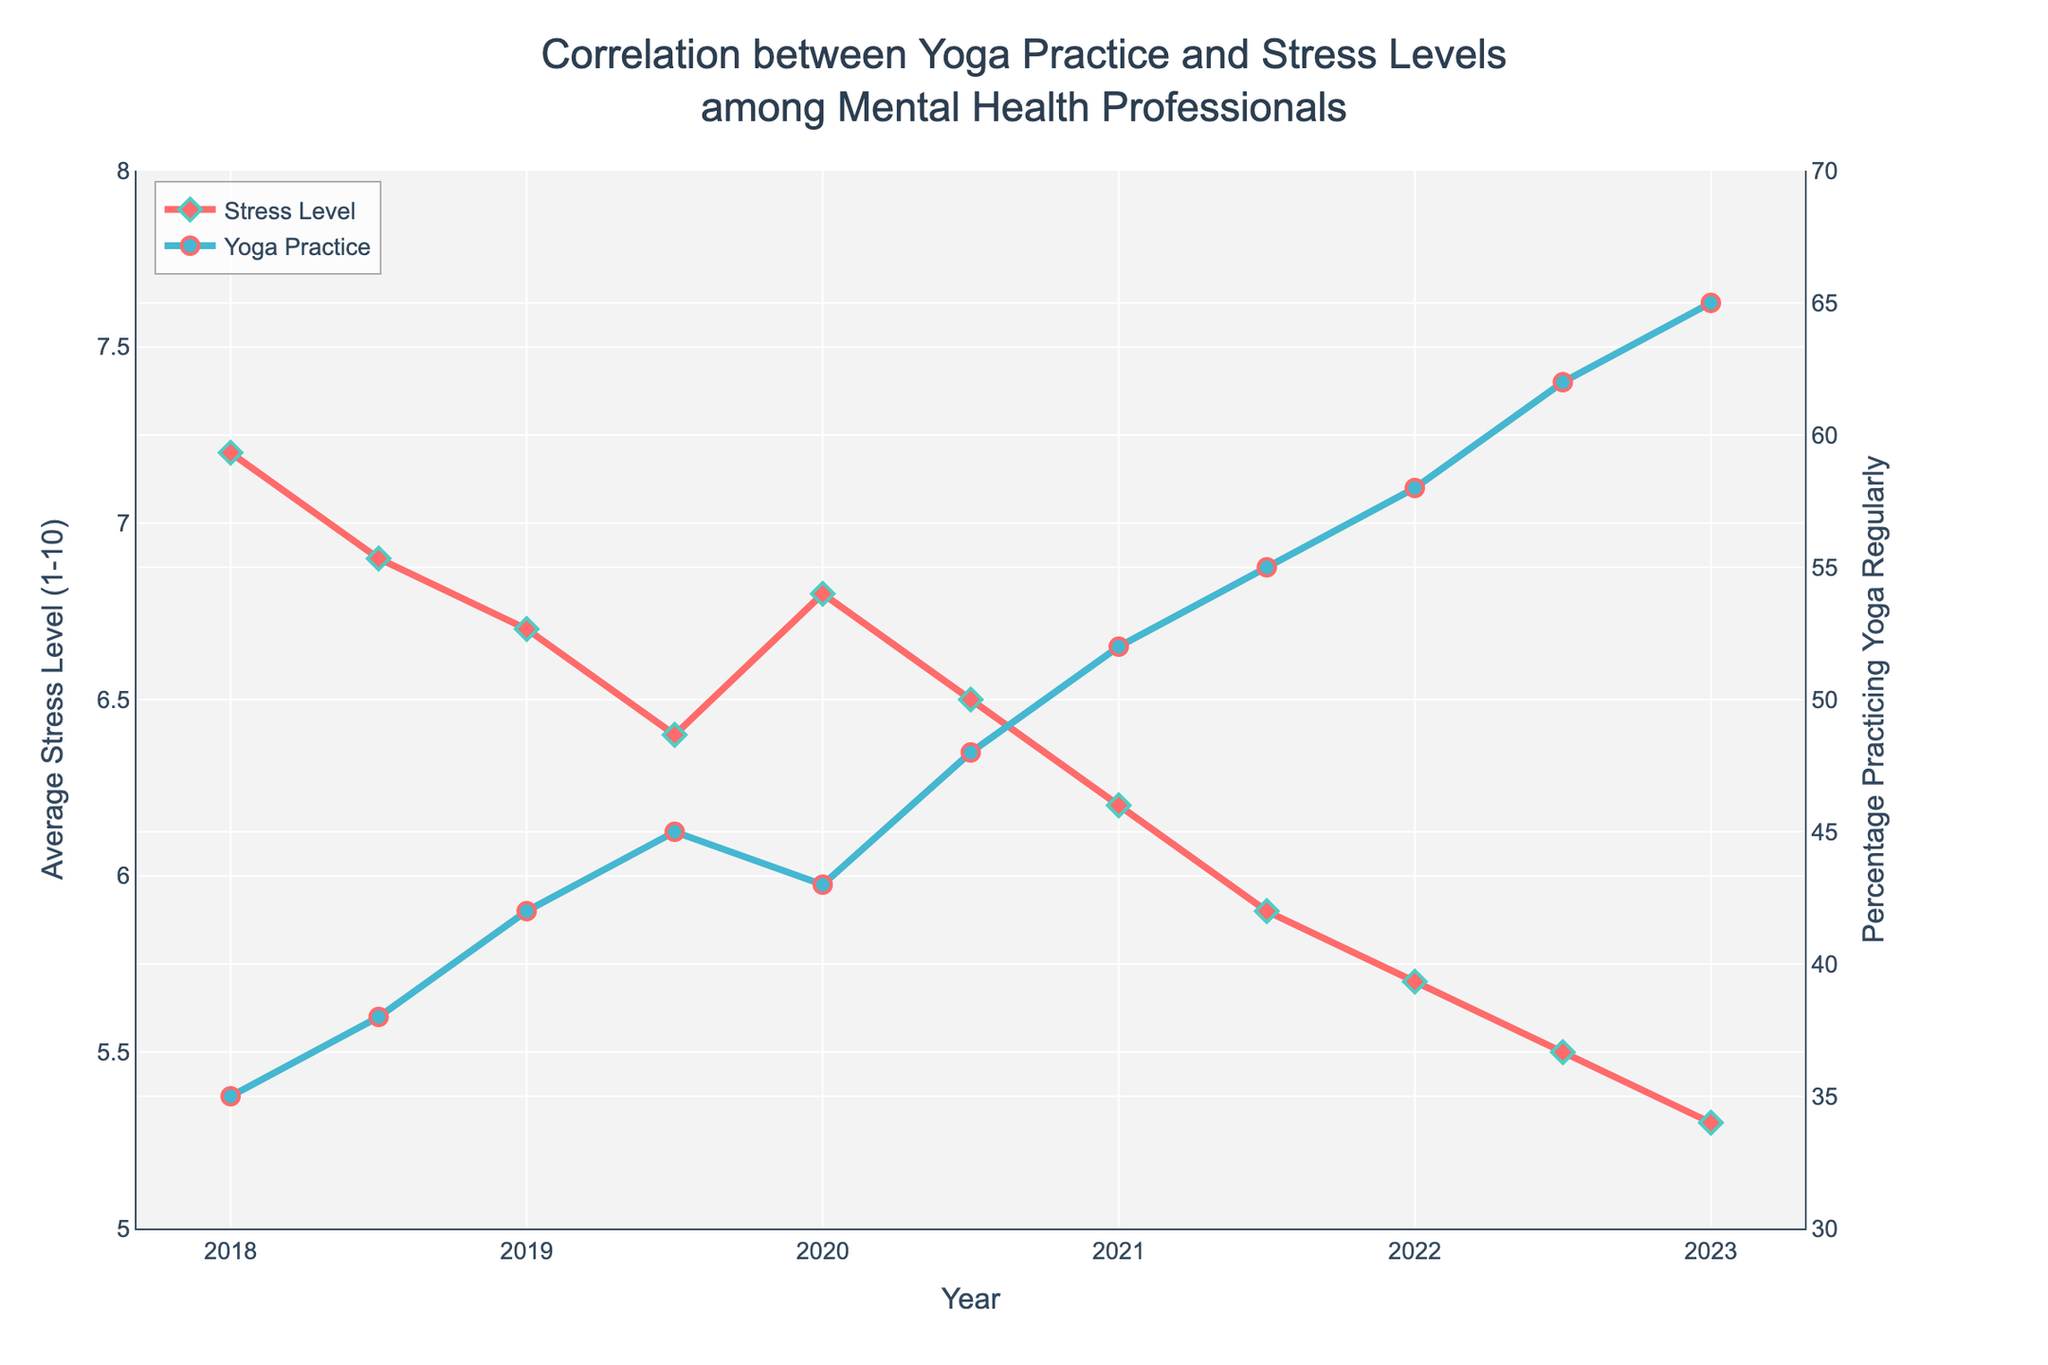What trend do you observe in the stress levels from 2018 to 2023? Observing the red line representing stress levels, it starts at 7.2 in 2018 and consistently decreases, reaching 5.3 by 2023.
Answer: Decreasing In which year was the highest percentage of mental health professionals practicing yoga regularly? Following the blue line indicating percentage yoga practice, it peaks at 65% in 2023.
Answer: 2023 What is the difference in the average stress levels between 2018 and 2023? The average stress level in 2018 is 7.2, while in 2023 it is 5.3. The difference is 7.2 - 5.3 = 1.9.
Answer: 1.9 How did the percentage of mental health professionals practicing yoga regularly change between 2020.5 and 2021.5? In 2020.5, 48% were practicing yoga regularly, while in 2021.5, it was 55%. The change is 55% - 48% = 7%.
Answer: 7% Which year between 2020 and 2023 saw the largest decline in stress levels? From 2020 to 2020.5, the stress level decreases from 6.8 to 6.5. Between 2020.5 and 2021, it declines from 6.5 to 6.2. The drop from 2021 to 2021.5 is from 6.2 to 5.9, and from 2021.5 to 2022 is from 5.9 to 5.7. Lastly, from 2022.5 to 2023, it goes from 5.5 to 5.3. The drop from 2021 to 2021.5 is the largest with a decrease of 0.3.
Answer: 2021 to 2021.5 What is the relationship between the trend in stress levels and the trend in yoga practice percentages from 2018 to 2023? The red line showing stress levels generally decreases, while the blue line representing yoga practice percentages increases over the same period. This suggests an inverse relationship where increasing yoga practice is associated with decreasing stress levels.
Answer: Inverse Estimate the average percentage of mental health professionals practicing yoga regularly over the 5-year period. The percentage values are 35, 38, 42, 45, 43, 48, 52, 55, 58, 62, and 65. Summing these gives 543. Dividing by 11 data points gives approximately 49.36%.
Answer: ~49.36% Which year showed an unexpected increase in stress levels compared to the previous half-year? The red line indicates an increase from 6.4 in 2019.5 to 6.8 in 2020.
Answer: 2020 At which point(s) do the stress level intersect the percentage practicing yoga regularly over the 5-year period? The two lines, red for stress levels and blue for yoga practice percentages, do not intersect at any point in the graph.
Answer: None 